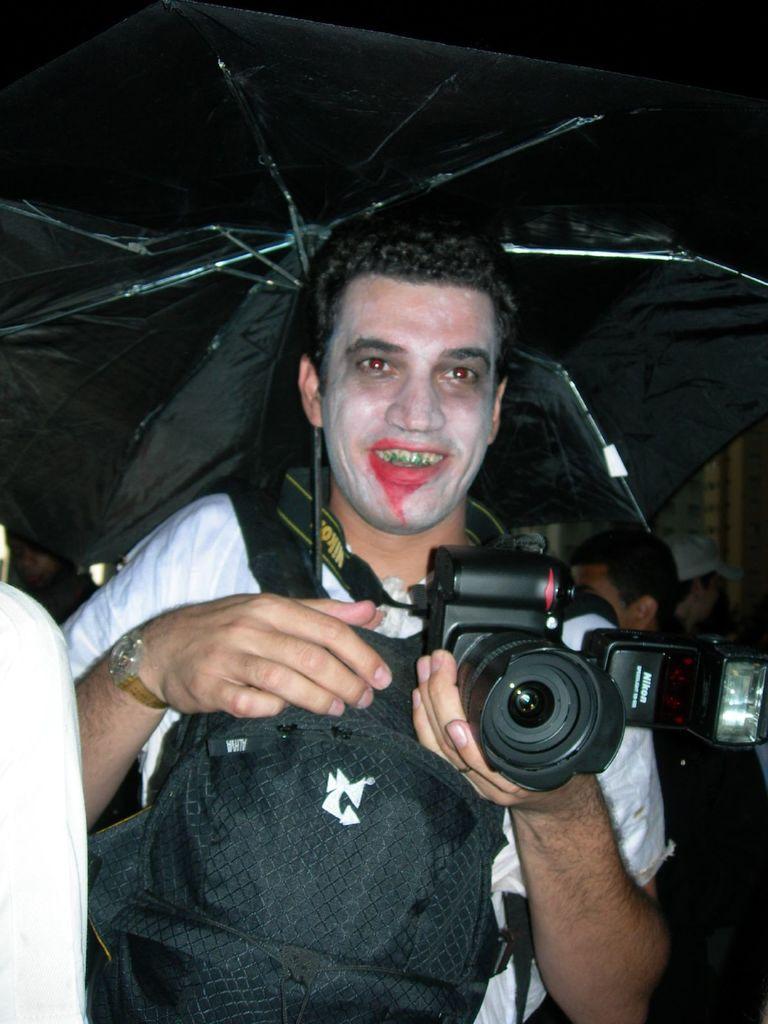Please provide a concise description of this image. In this picture we can see a man who is holding a camera with his hand. He is smiling and he is holding a umbrella. 